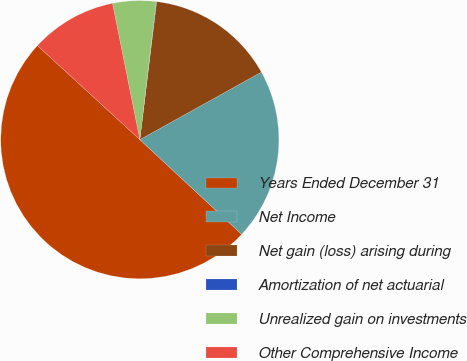Convert chart. <chart><loc_0><loc_0><loc_500><loc_500><pie_chart><fcel>Years Ended December 31<fcel>Net Income<fcel>Net gain (loss) arising during<fcel>Amortization of net actuarial<fcel>Unrealized gain on investments<fcel>Other Comprehensive Income<nl><fcel>49.9%<fcel>19.99%<fcel>15.0%<fcel>0.05%<fcel>5.03%<fcel>10.02%<nl></chart> 